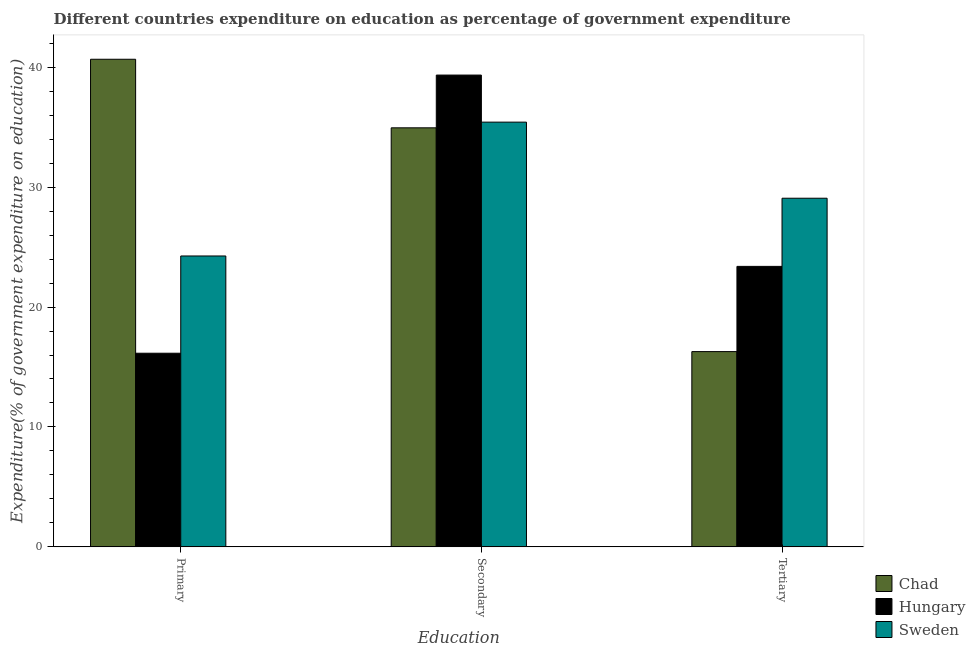How many different coloured bars are there?
Your answer should be compact. 3. How many groups of bars are there?
Your answer should be very brief. 3. Are the number of bars per tick equal to the number of legend labels?
Offer a very short reply. Yes. Are the number of bars on each tick of the X-axis equal?
Your answer should be compact. Yes. How many bars are there on the 3rd tick from the right?
Your answer should be compact. 3. What is the label of the 3rd group of bars from the left?
Give a very brief answer. Tertiary. What is the expenditure on tertiary education in Sweden?
Give a very brief answer. 29.08. Across all countries, what is the maximum expenditure on primary education?
Provide a succinct answer. 40.67. Across all countries, what is the minimum expenditure on secondary education?
Provide a short and direct response. 34.95. In which country was the expenditure on tertiary education maximum?
Keep it short and to the point. Sweden. In which country was the expenditure on secondary education minimum?
Make the answer very short. Chad. What is the total expenditure on secondary education in the graph?
Give a very brief answer. 109.72. What is the difference between the expenditure on tertiary education in Chad and that in Sweden?
Keep it short and to the point. -12.79. What is the difference between the expenditure on secondary education in Hungary and the expenditure on primary education in Sweden?
Your response must be concise. 15.09. What is the average expenditure on tertiary education per country?
Ensure brevity in your answer.  22.92. What is the difference between the expenditure on tertiary education and expenditure on primary education in Sweden?
Your answer should be compact. 4.82. What is the ratio of the expenditure on tertiary education in Hungary to that in Chad?
Your answer should be compact. 1.44. What is the difference between the highest and the second highest expenditure on primary education?
Your response must be concise. 16.41. What is the difference between the highest and the lowest expenditure on tertiary education?
Offer a very short reply. 12.79. What does the 3rd bar from the left in Primary represents?
Provide a short and direct response. Sweden. What does the 3rd bar from the right in Tertiary represents?
Your response must be concise. Chad. Is it the case that in every country, the sum of the expenditure on primary education and expenditure on secondary education is greater than the expenditure on tertiary education?
Your answer should be very brief. Yes. How many bars are there?
Provide a succinct answer. 9. How many legend labels are there?
Your answer should be compact. 3. How are the legend labels stacked?
Provide a short and direct response. Vertical. What is the title of the graph?
Offer a very short reply. Different countries expenditure on education as percentage of government expenditure. What is the label or title of the X-axis?
Your answer should be very brief. Education. What is the label or title of the Y-axis?
Offer a terse response. Expenditure(% of government expenditure on education). What is the Expenditure(% of government expenditure on education) in Chad in Primary?
Give a very brief answer. 40.67. What is the Expenditure(% of government expenditure on education) of Hungary in Primary?
Make the answer very short. 16.15. What is the Expenditure(% of government expenditure on education) of Sweden in Primary?
Ensure brevity in your answer.  24.26. What is the Expenditure(% of government expenditure on education) of Chad in Secondary?
Ensure brevity in your answer.  34.95. What is the Expenditure(% of government expenditure on education) in Hungary in Secondary?
Your response must be concise. 39.35. What is the Expenditure(% of government expenditure on education) of Sweden in Secondary?
Provide a succinct answer. 35.42. What is the Expenditure(% of government expenditure on education) in Chad in Tertiary?
Ensure brevity in your answer.  16.28. What is the Expenditure(% of government expenditure on education) of Hungary in Tertiary?
Your answer should be very brief. 23.39. What is the Expenditure(% of government expenditure on education) of Sweden in Tertiary?
Offer a terse response. 29.08. Across all Education, what is the maximum Expenditure(% of government expenditure on education) in Chad?
Provide a succinct answer. 40.67. Across all Education, what is the maximum Expenditure(% of government expenditure on education) of Hungary?
Give a very brief answer. 39.35. Across all Education, what is the maximum Expenditure(% of government expenditure on education) of Sweden?
Provide a succinct answer. 35.42. Across all Education, what is the minimum Expenditure(% of government expenditure on education) of Chad?
Your answer should be very brief. 16.28. Across all Education, what is the minimum Expenditure(% of government expenditure on education) of Hungary?
Offer a terse response. 16.15. Across all Education, what is the minimum Expenditure(% of government expenditure on education) of Sweden?
Your answer should be compact. 24.26. What is the total Expenditure(% of government expenditure on education) of Chad in the graph?
Offer a terse response. 91.9. What is the total Expenditure(% of government expenditure on education) in Hungary in the graph?
Provide a short and direct response. 78.89. What is the total Expenditure(% of government expenditure on education) of Sweden in the graph?
Provide a succinct answer. 88.76. What is the difference between the Expenditure(% of government expenditure on education) of Chad in Primary and that in Secondary?
Your response must be concise. 5.72. What is the difference between the Expenditure(% of government expenditure on education) in Hungary in Primary and that in Secondary?
Make the answer very short. -23.2. What is the difference between the Expenditure(% of government expenditure on education) of Sweden in Primary and that in Secondary?
Make the answer very short. -11.16. What is the difference between the Expenditure(% of government expenditure on education) of Chad in Primary and that in Tertiary?
Give a very brief answer. 24.38. What is the difference between the Expenditure(% of government expenditure on education) of Hungary in Primary and that in Tertiary?
Provide a succinct answer. -7.24. What is the difference between the Expenditure(% of government expenditure on education) of Sweden in Primary and that in Tertiary?
Ensure brevity in your answer.  -4.82. What is the difference between the Expenditure(% of government expenditure on education) of Chad in Secondary and that in Tertiary?
Make the answer very short. 18.66. What is the difference between the Expenditure(% of government expenditure on education) of Hungary in Secondary and that in Tertiary?
Provide a short and direct response. 15.96. What is the difference between the Expenditure(% of government expenditure on education) in Sweden in Secondary and that in Tertiary?
Your answer should be compact. 6.35. What is the difference between the Expenditure(% of government expenditure on education) of Chad in Primary and the Expenditure(% of government expenditure on education) of Hungary in Secondary?
Make the answer very short. 1.32. What is the difference between the Expenditure(% of government expenditure on education) of Chad in Primary and the Expenditure(% of government expenditure on education) of Sweden in Secondary?
Make the answer very short. 5.24. What is the difference between the Expenditure(% of government expenditure on education) of Hungary in Primary and the Expenditure(% of government expenditure on education) of Sweden in Secondary?
Give a very brief answer. -19.27. What is the difference between the Expenditure(% of government expenditure on education) of Chad in Primary and the Expenditure(% of government expenditure on education) of Hungary in Tertiary?
Your answer should be compact. 17.27. What is the difference between the Expenditure(% of government expenditure on education) of Chad in Primary and the Expenditure(% of government expenditure on education) of Sweden in Tertiary?
Your answer should be compact. 11.59. What is the difference between the Expenditure(% of government expenditure on education) in Hungary in Primary and the Expenditure(% of government expenditure on education) in Sweden in Tertiary?
Your answer should be very brief. -12.93. What is the difference between the Expenditure(% of government expenditure on education) of Chad in Secondary and the Expenditure(% of government expenditure on education) of Hungary in Tertiary?
Offer a terse response. 11.56. What is the difference between the Expenditure(% of government expenditure on education) of Chad in Secondary and the Expenditure(% of government expenditure on education) of Sweden in Tertiary?
Your answer should be compact. 5.87. What is the difference between the Expenditure(% of government expenditure on education) in Hungary in Secondary and the Expenditure(% of government expenditure on education) in Sweden in Tertiary?
Your answer should be compact. 10.27. What is the average Expenditure(% of government expenditure on education) of Chad per Education?
Provide a short and direct response. 30.63. What is the average Expenditure(% of government expenditure on education) in Hungary per Education?
Offer a very short reply. 26.3. What is the average Expenditure(% of government expenditure on education) in Sweden per Education?
Make the answer very short. 29.59. What is the difference between the Expenditure(% of government expenditure on education) of Chad and Expenditure(% of government expenditure on education) of Hungary in Primary?
Offer a terse response. 24.52. What is the difference between the Expenditure(% of government expenditure on education) in Chad and Expenditure(% of government expenditure on education) in Sweden in Primary?
Offer a very short reply. 16.41. What is the difference between the Expenditure(% of government expenditure on education) in Hungary and Expenditure(% of government expenditure on education) in Sweden in Primary?
Your answer should be compact. -8.11. What is the difference between the Expenditure(% of government expenditure on education) of Chad and Expenditure(% of government expenditure on education) of Hungary in Secondary?
Make the answer very short. -4.4. What is the difference between the Expenditure(% of government expenditure on education) of Chad and Expenditure(% of government expenditure on education) of Sweden in Secondary?
Your answer should be compact. -0.47. What is the difference between the Expenditure(% of government expenditure on education) of Hungary and Expenditure(% of government expenditure on education) of Sweden in Secondary?
Give a very brief answer. 3.93. What is the difference between the Expenditure(% of government expenditure on education) in Chad and Expenditure(% of government expenditure on education) in Hungary in Tertiary?
Keep it short and to the point. -7.11. What is the difference between the Expenditure(% of government expenditure on education) of Chad and Expenditure(% of government expenditure on education) of Sweden in Tertiary?
Give a very brief answer. -12.79. What is the difference between the Expenditure(% of government expenditure on education) of Hungary and Expenditure(% of government expenditure on education) of Sweden in Tertiary?
Provide a succinct answer. -5.68. What is the ratio of the Expenditure(% of government expenditure on education) in Chad in Primary to that in Secondary?
Offer a terse response. 1.16. What is the ratio of the Expenditure(% of government expenditure on education) in Hungary in Primary to that in Secondary?
Provide a succinct answer. 0.41. What is the ratio of the Expenditure(% of government expenditure on education) in Sweden in Primary to that in Secondary?
Give a very brief answer. 0.68. What is the ratio of the Expenditure(% of government expenditure on education) in Chad in Primary to that in Tertiary?
Offer a terse response. 2.5. What is the ratio of the Expenditure(% of government expenditure on education) of Hungary in Primary to that in Tertiary?
Provide a short and direct response. 0.69. What is the ratio of the Expenditure(% of government expenditure on education) in Sweden in Primary to that in Tertiary?
Your answer should be compact. 0.83. What is the ratio of the Expenditure(% of government expenditure on education) of Chad in Secondary to that in Tertiary?
Provide a succinct answer. 2.15. What is the ratio of the Expenditure(% of government expenditure on education) of Hungary in Secondary to that in Tertiary?
Your response must be concise. 1.68. What is the ratio of the Expenditure(% of government expenditure on education) of Sweden in Secondary to that in Tertiary?
Ensure brevity in your answer.  1.22. What is the difference between the highest and the second highest Expenditure(% of government expenditure on education) in Chad?
Keep it short and to the point. 5.72. What is the difference between the highest and the second highest Expenditure(% of government expenditure on education) of Hungary?
Ensure brevity in your answer.  15.96. What is the difference between the highest and the second highest Expenditure(% of government expenditure on education) of Sweden?
Keep it short and to the point. 6.35. What is the difference between the highest and the lowest Expenditure(% of government expenditure on education) of Chad?
Offer a very short reply. 24.38. What is the difference between the highest and the lowest Expenditure(% of government expenditure on education) of Hungary?
Give a very brief answer. 23.2. What is the difference between the highest and the lowest Expenditure(% of government expenditure on education) of Sweden?
Your answer should be very brief. 11.16. 